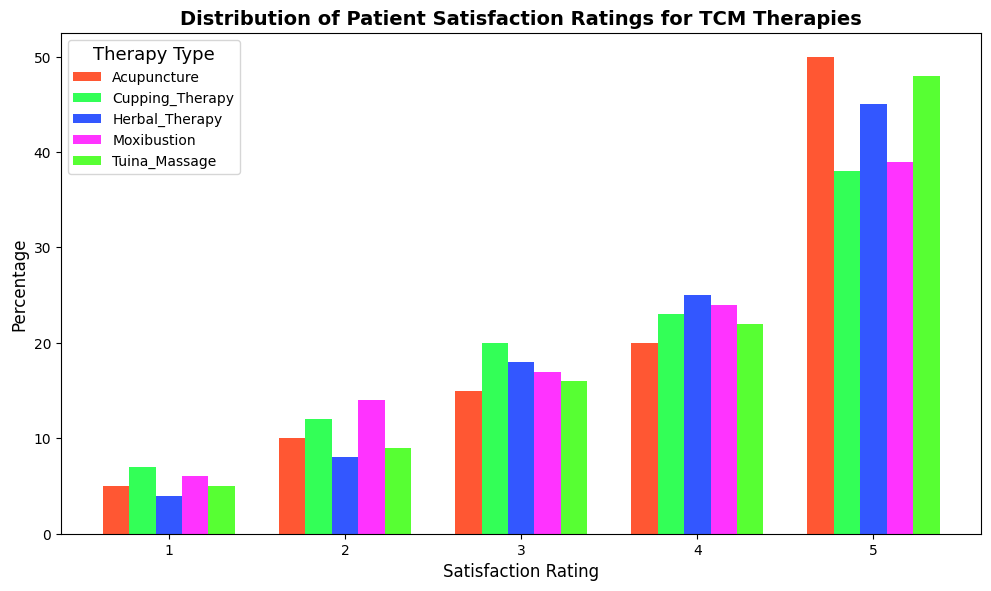Which therapy type has the highest percentage of satisfaction rating 5? To determine this, look at all the bars for satisfaction rating 5 and identify which is the tallest. Acupuncture has the highest bar at 50%.
Answer: Acupuncture Which therapy has the lowest percentage for satisfaction rating 1? Compare the heights of the bars for satisfaction rating 1 across all therapies. Herbal Therapy has the lowest bar at 4%.
Answer: Herbal Therapy What is the average percentage of satisfaction rating 4 for Acupuncture, Herbal Therapy, and Cupping Therapy? Add the percentages of satisfaction rating 4 for these therapies: 20% (Acupuncture) + 25% (Herbal Therapy) + 23% (Cupping Therapy) = 68%. Then, divide by 3: 68% / 3 = 22.67%.
Answer: 22.67% Which therapy type has a satisfaction rating distribution that frequently rises from one rating to the next? Observe each therapy's bars to see which show a consistent increase from rating 1 to rating 5. For example, Herbal Therapy generally rises or increases.
Answer: Herbal Therapy For which satisfaction rating does Moxibustion have the closest percentage to the overall average of all therapies for that rating? Calculate the overall average for each satisfaction rating and then find which Moxibustion percentage is closest. For rating 2: (10% + 8% + 12% + 14% + 9%) / 5 = 10.6%. Moxibustion has 14%, and for other ratings: 23.4% (rating 3),., etc. So rating 2 for Moxibustion is the closest to the overall average.
Answer: Satisfaction Rating 2 Which satisfaction rating shows the largest percentage difference between Acupuncture and Tuina Massage? Calculate the absolute differences for each satisfaction rating: 5%, 1%, 1%, 2%, and 2%. Satisfaction rating 2 has a difference of 1% and 5%. The largest difference is at rating 5 with 2%.
Answer: Satisfaction Rating 4 